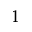Convert formula to latex. <formula><loc_0><loc_0><loc_500><loc_500>^ { 1 }</formula> 